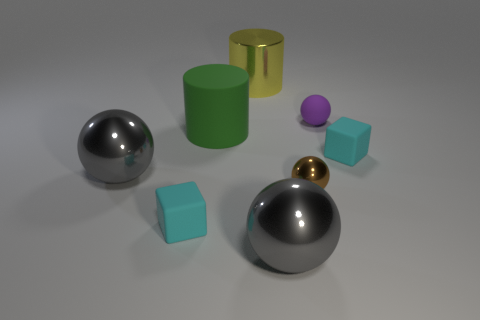Subtract all small metallic spheres. How many spheres are left? 3 Subtract all green cylinders. How many cylinders are left? 1 Subtract 1 cylinders. How many cylinders are left? 1 Subtract all green spheres. How many yellow cylinders are left? 1 Add 1 tiny purple rubber spheres. How many objects exist? 9 Subtract all cylinders. How many objects are left? 6 Add 8 large yellow things. How many large yellow things exist? 9 Subtract 0 blue cylinders. How many objects are left? 8 Subtract all red blocks. Subtract all gray balls. How many blocks are left? 2 Subtract all big yellow metal objects. Subtract all green cylinders. How many objects are left? 6 